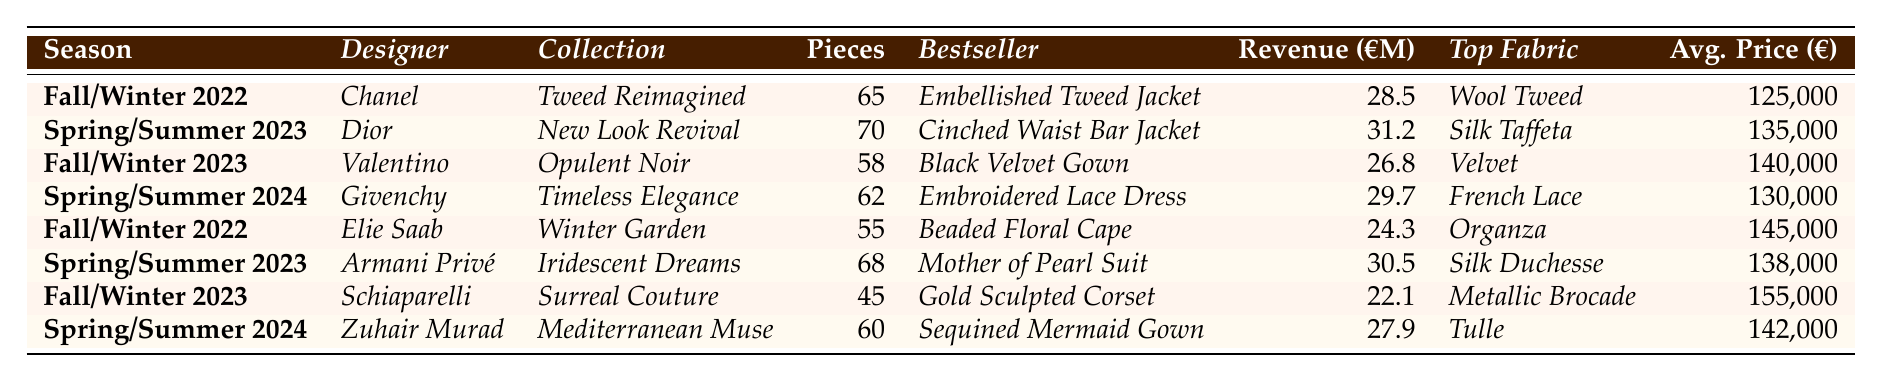What is the total revenue generated by the "New Look Revival" collection? According to the table, the "New Look Revival" collection by Dior generated revenue of €31.2 million.
Answer: €31.2 million Which collection had the highest average price per piece? By comparing the average prices in the table, the highest is for "Gold Sculpted Corset" with €155,000.
Answer: €155,000 How many pieces were included in the "Timeless Elegance" collection? The table states that the "Timeless Elegance" collection contains 62 pieces.
Answer: 62 What is the bestseller in the "Opulent Noir" collection? The bestseller listed for the "Opulent Noir" collection is the "Black Velvet Gown."
Answer: Black Velvet Gown Which season had the lowest total revenue? Comparing total revenues from each season, the lowest revenue is from "Surreal Couture" during Fall/Winter 2023 at €22.1 million.
Answer: €22.1 million What is the total number of pieces from all collections listed in Fall/Winter 2022? Adding the pieces from both collections in Fall/Winter 2022: 65 (Chanel) + 55 (Elie Saab) = 120 pieces.
Answer: 120 Is "Silk Taffeta" used as the most popular fabric in the Spring/Summer 2023 collection? According to the table, "Silk Taffeta" is indeed the most used fabric for the Spring/Summer 2023 collection by Dior.
Answer: Yes What is the average price per piece for the collections in Spring/Summer 2024? The average price per piece for the collections in Spring/Summer 2024 is calculated as (130,000 + 142,000) / 2 = 136,000.
Answer: €136,000 Which designer had the highest single collection revenue? Upon reviewing the revenue figures, the highest is from Dior with the "New Look Revival" collection at €31.2 million.
Answer: Dior How many more pieces did the "Iridescent Dreams" collection have than the "Surreal Couture"? The "Iridescent Dreams" collection had 68 pieces and "Surreal Couture" had 45 pieces, so the difference is 68 - 45 = 23 pieces.
Answer: 23 